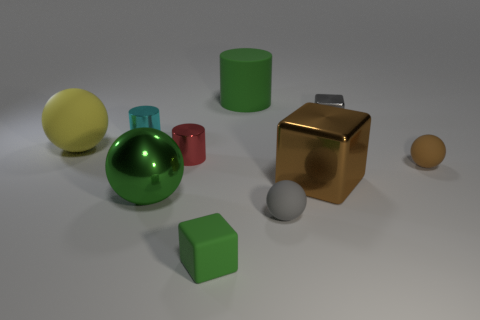Is the material of the big yellow object the same as the brown block? Upon visual inspection, it appears that the big yellow object and the brown block have different surface properties, which suggests that they are made of different materials. The yellow object has a matte finish, likely indicating a plastic-like material, while the brown block has a more reflective surface, which suggests a metallic composition. 